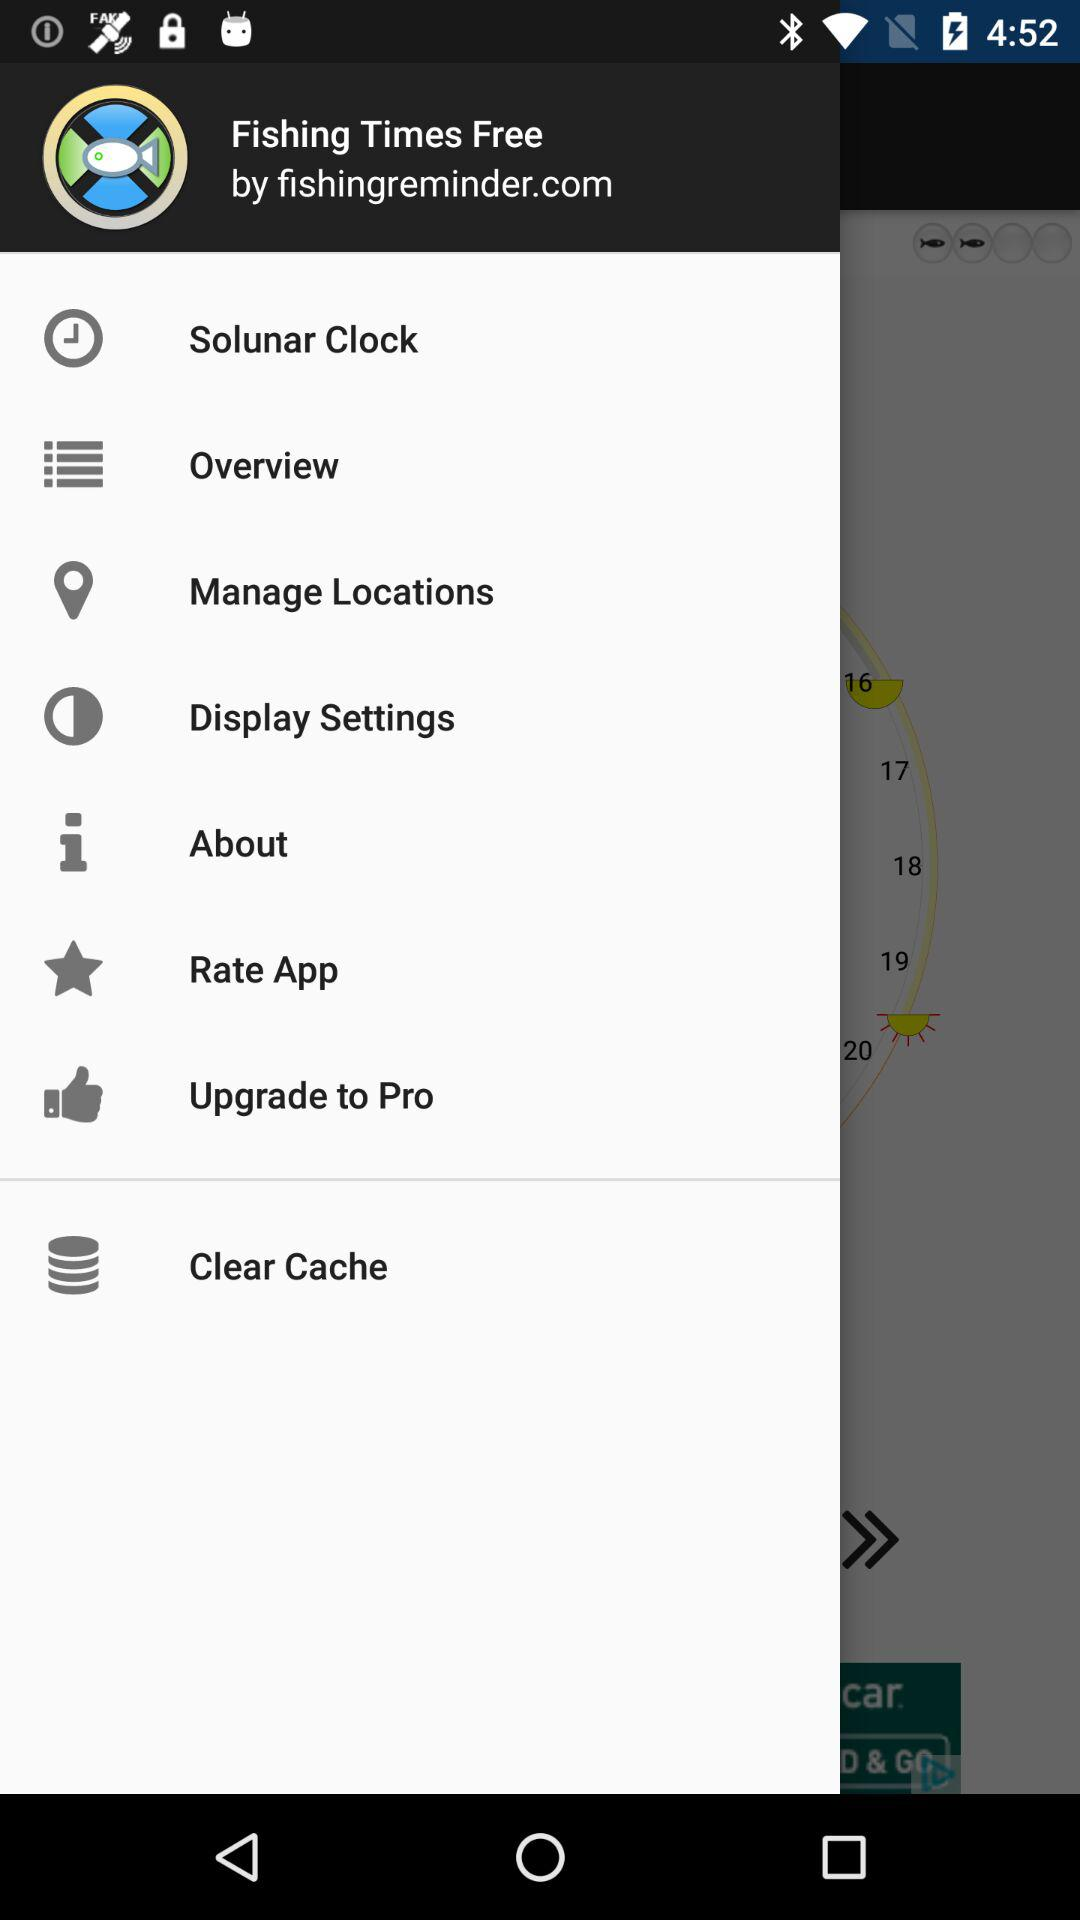What is the application name? The application name is "Fishing Times Free". 